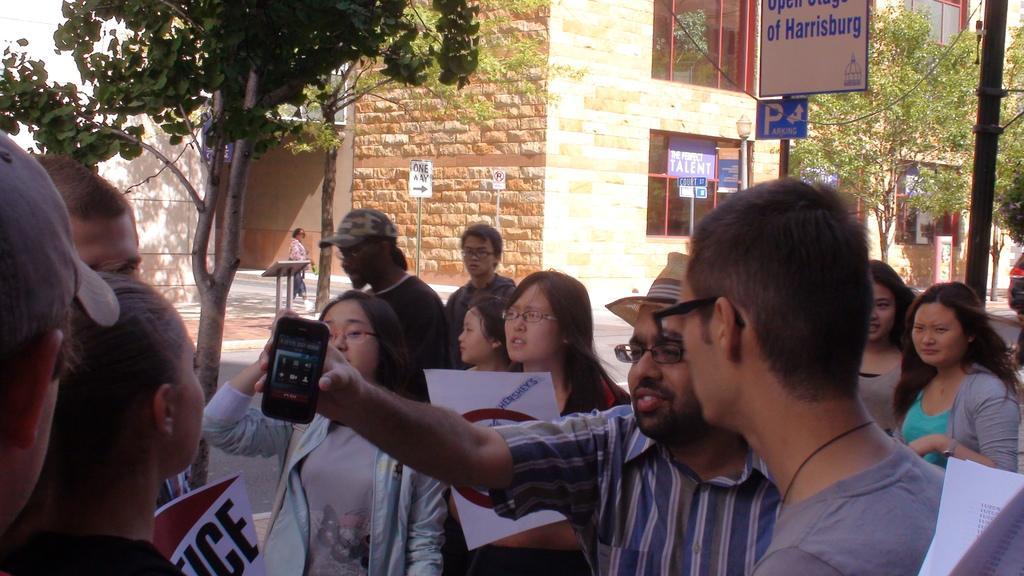How would you summarize this image in a sentence or two? In this image we can see people standing. The man standing in the center is holding a mobile. Some of them are holding papers. In the background there are buildings, trees, boards and poles. 